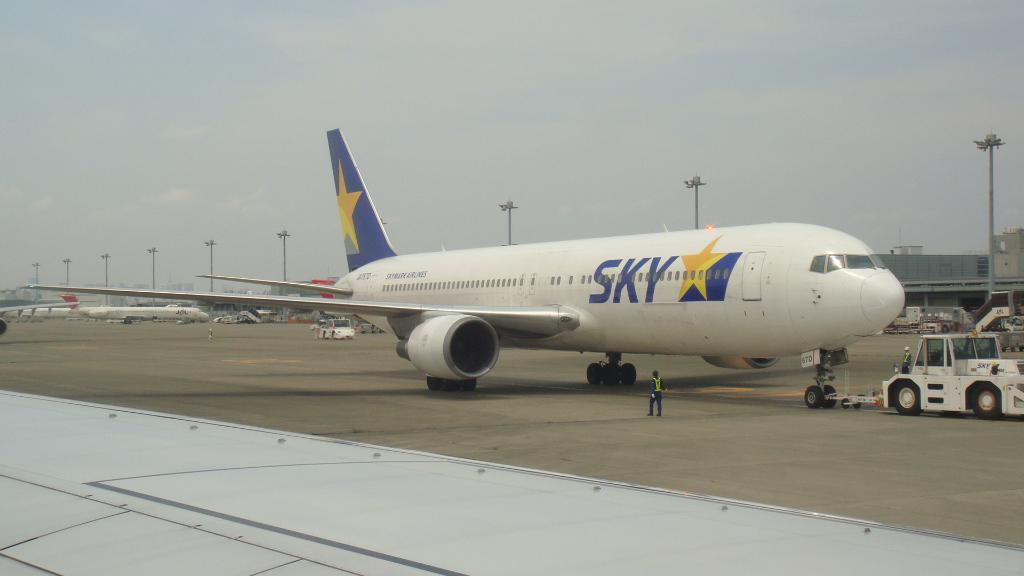What type of transportation is shown in the image? There are aeroplanes and vehicles in the image. Can you describe the people in the image? There are people in the image. What are the poles with lights used for in the image? The poles with lights are likely used for illumination or signaling purposes. What is the main surface in the image? There is a road in the image. What can be seen in the background of the image? The sky is visible in the background of the image. Where is the desk located in the image? There is no desk present in the image. What type of shoes are the people wearing in the image? There is no information about the shoes the people are wearing in the image. 